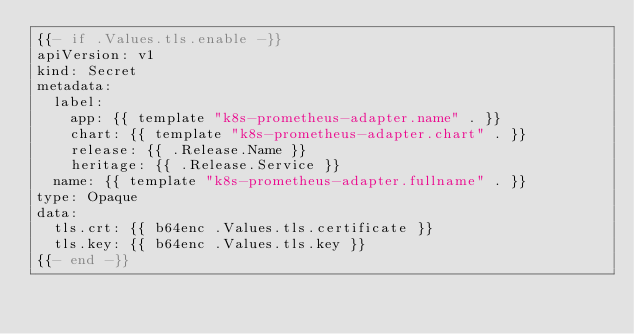Convert code to text. <code><loc_0><loc_0><loc_500><loc_500><_YAML_>{{- if .Values.tls.enable -}}
apiVersion: v1
kind: Secret
metadata:
  label:
    app: {{ template "k8s-prometheus-adapter.name" . }}
    chart: {{ template "k8s-prometheus-adapter.chart" . }}
    release: {{ .Release.Name }}
    heritage: {{ .Release.Service }}
  name: {{ template "k8s-prometheus-adapter.fullname" . }}
type: Opaque
data:
  tls.crt: {{ b64enc .Values.tls.certificate }}
  tls.key: {{ b64enc .Values.tls.key }}
{{- end -}}
</code> 